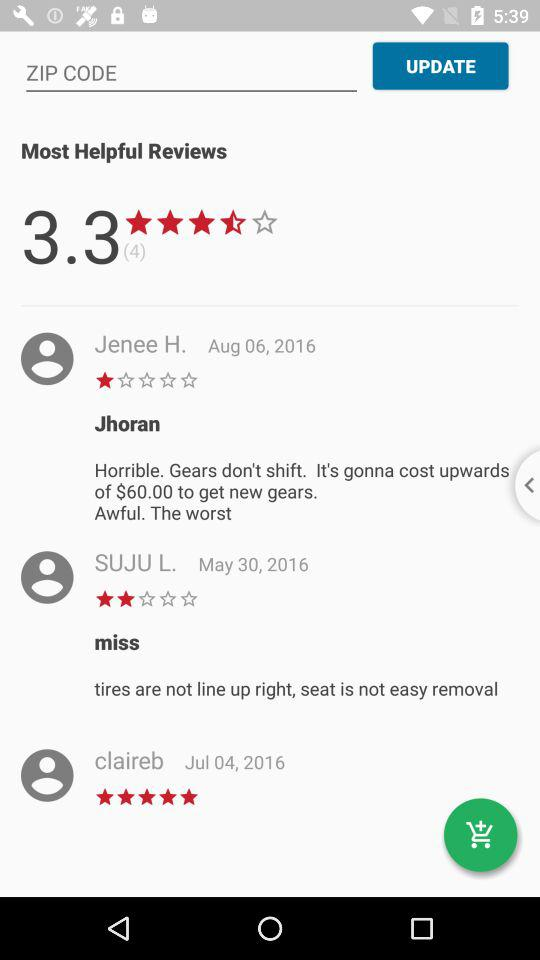What is the star rating given by Jenee H.? The star rating given by Jenee H. is 1 star. 